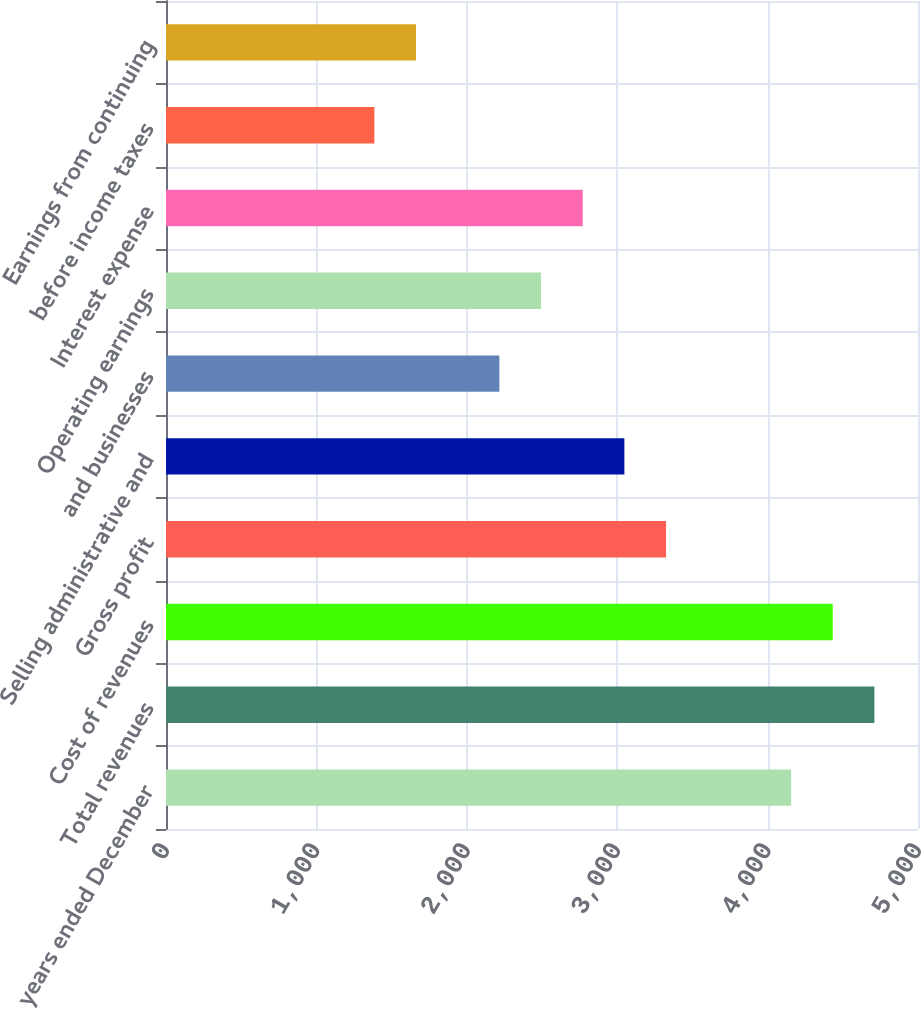Convert chart. <chart><loc_0><loc_0><loc_500><loc_500><bar_chart><fcel>For the years ended December<fcel>Total revenues<fcel>Cost of revenues<fcel>Gross profit<fcel>Selling administrative and<fcel>and businesses<fcel>Operating earnings<fcel>Interest expense<fcel>before income taxes<fcel>Earnings from continuing<nl><fcel>4156.08<fcel>4710.22<fcel>4433.15<fcel>3324.87<fcel>3047.8<fcel>2216.59<fcel>2493.66<fcel>2770.73<fcel>1385.38<fcel>1662.45<nl></chart> 